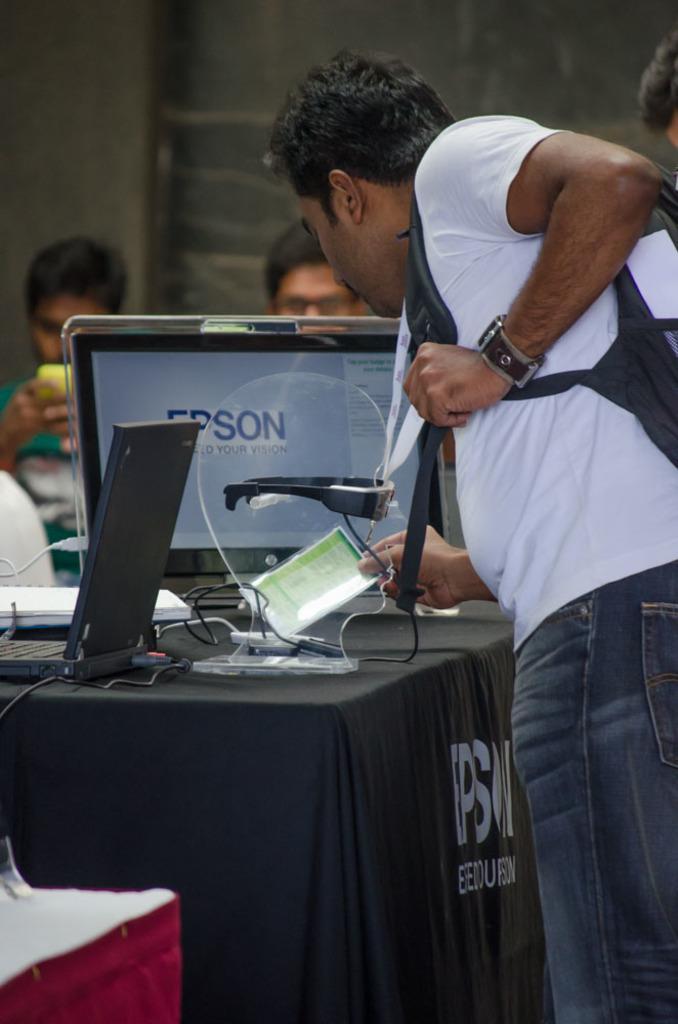Describe this image in one or two sentences. In this picture we can see a man standing a paper, in the background we can see two people, on left side man is holding a mobile phone, here we can see a table and it consists of monitor and also we can see a cloth here. 